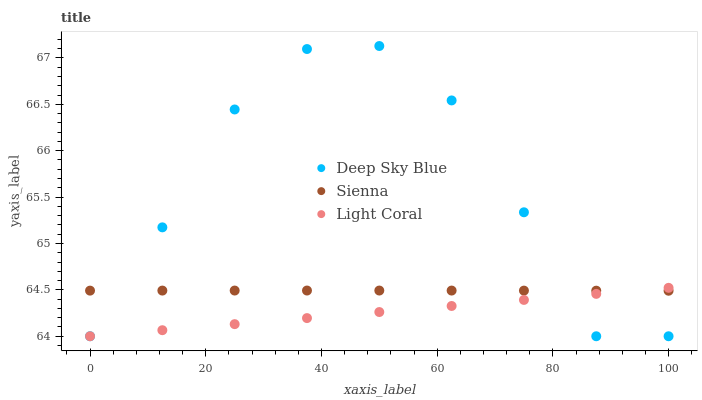Does Light Coral have the minimum area under the curve?
Answer yes or no. Yes. Does Deep Sky Blue have the maximum area under the curve?
Answer yes or no. Yes. Does Deep Sky Blue have the minimum area under the curve?
Answer yes or no. No. Does Light Coral have the maximum area under the curve?
Answer yes or no. No. Is Light Coral the smoothest?
Answer yes or no. Yes. Is Deep Sky Blue the roughest?
Answer yes or no. Yes. Is Deep Sky Blue the smoothest?
Answer yes or no. No. Is Light Coral the roughest?
Answer yes or no. No. Does Light Coral have the lowest value?
Answer yes or no. Yes. Does Deep Sky Blue have the highest value?
Answer yes or no. Yes. Does Light Coral have the highest value?
Answer yes or no. No. Does Sienna intersect Deep Sky Blue?
Answer yes or no. Yes. Is Sienna less than Deep Sky Blue?
Answer yes or no. No. Is Sienna greater than Deep Sky Blue?
Answer yes or no. No. 